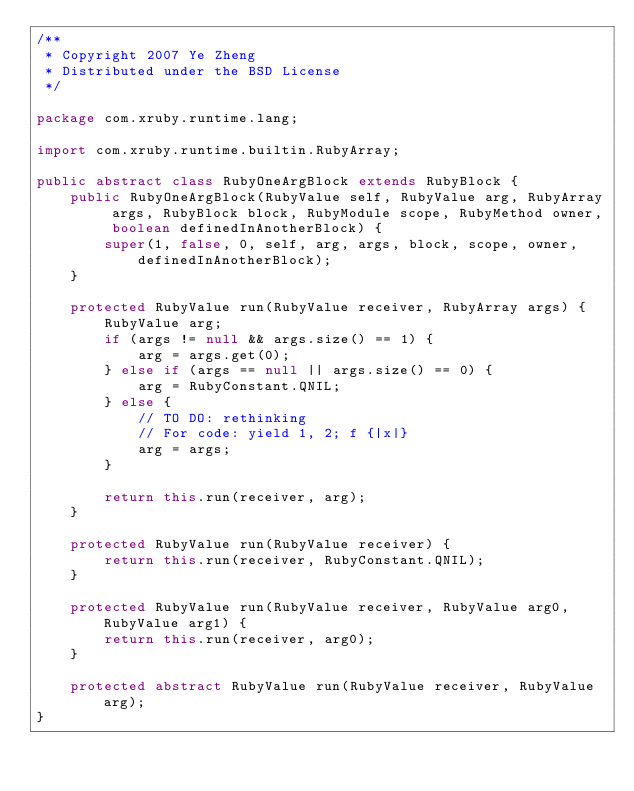Convert code to text. <code><loc_0><loc_0><loc_500><loc_500><_Java_>/**
 * Copyright 2007 Ye Zheng
 * Distributed under the BSD License
 */

package com.xruby.runtime.lang;

import com.xruby.runtime.builtin.RubyArray;

public abstract class RubyOneArgBlock extends RubyBlock {
    public RubyOneArgBlock(RubyValue self, RubyValue arg, RubyArray args, RubyBlock block, RubyModule scope, RubyMethod owner, boolean definedInAnotherBlock) {
        super(1, false, 0, self, arg, args, block, scope, owner, definedInAnotherBlock);
    }

    protected RubyValue run(RubyValue receiver, RubyArray args) {
        RubyValue arg;
        if (args != null && args.size() == 1) {
            arg = args.get(0);
        } else if (args == null || args.size() == 0) {
            arg = RubyConstant.QNIL;
        } else {
            // TO DO: rethinking
            // For code: yield 1, 2; f {|x|}
            arg = args;
        }

        return this.run(receiver, arg);
    }

    protected RubyValue run(RubyValue receiver) {
        return this.run(receiver, RubyConstant.QNIL);
    }

    protected RubyValue run(RubyValue receiver, RubyValue arg0, RubyValue arg1) {
        return this.run(receiver, arg0);
    }

    protected abstract RubyValue run(RubyValue receiver, RubyValue arg);
}</code> 